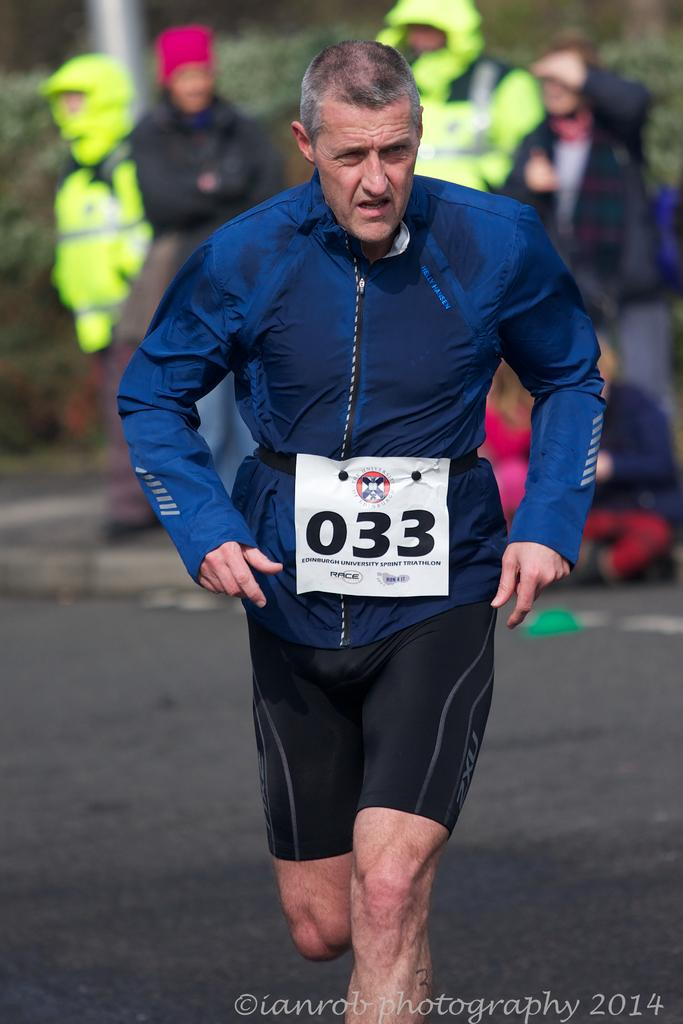What is there is a person engaged in physical activity in the image? Yes, there is a person running on the road in the image. What can be seen in the background of the image? There are people standing on the footpath in the background. Can you describe any distinguishing features of the person running? The person running has a badge on their shirt. What type of drink is being consumed by the person running in the image? There is no drink present in the image; the person running is not consuming anything. 